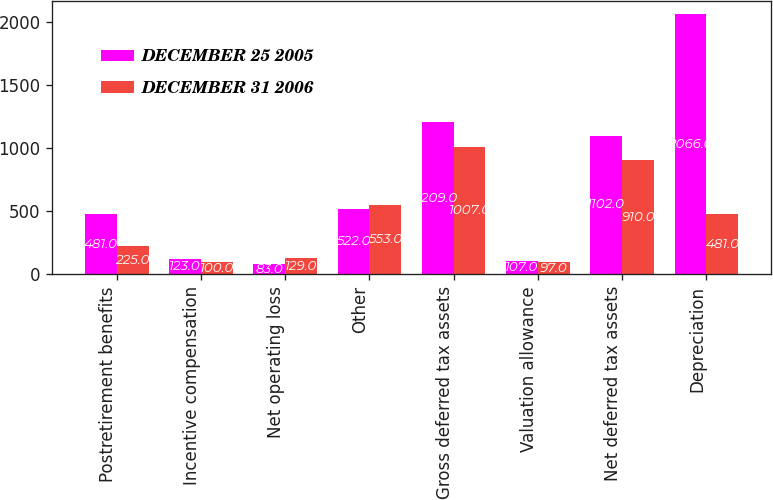Convert chart to OTSL. <chart><loc_0><loc_0><loc_500><loc_500><stacked_bar_chart><ecel><fcel>Postretirement benefits<fcel>Incentive compensation<fcel>Net operating loss<fcel>Other<fcel>Gross deferred tax assets<fcel>Valuation allowance<fcel>Net deferred tax assets<fcel>Depreciation<nl><fcel>DECEMBER 25 2005<fcel>481<fcel>123<fcel>83<fcel>522<fcel>1209<fcel>107<fcel>1102<fcel>2066<nl><fcel>DECEMBER 31 2006<fcel>225<fcel>100<fcel>129<fcel>553<fcel>1007<fcel>97<fcel>910<fcel>481<nl></chart> 